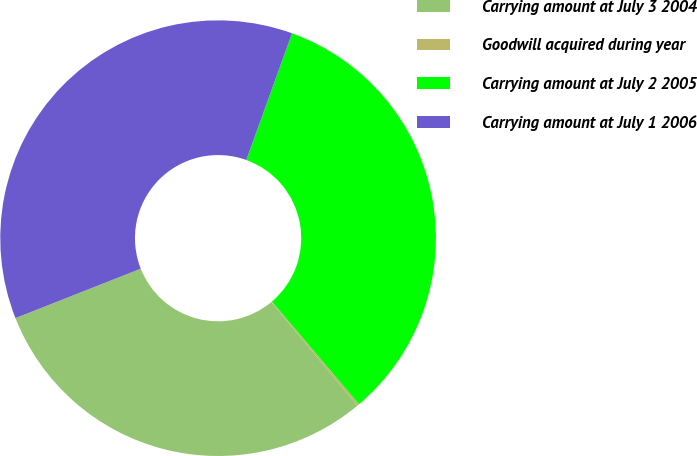Convert chart. <chart><loc_0><loc_0><loc_500><loc_500><pie_chart><fcel>Carrying amount at July 3 2004<fcel>Goodwill acquired during year<fcel>Carrying amount at July 2 2005<fcel>Carrying amount at July 1 2006<nl><fcel>30.06%<fcel>0.16%<fcel>33.28%<fcel>36.49%<nl></chart> 